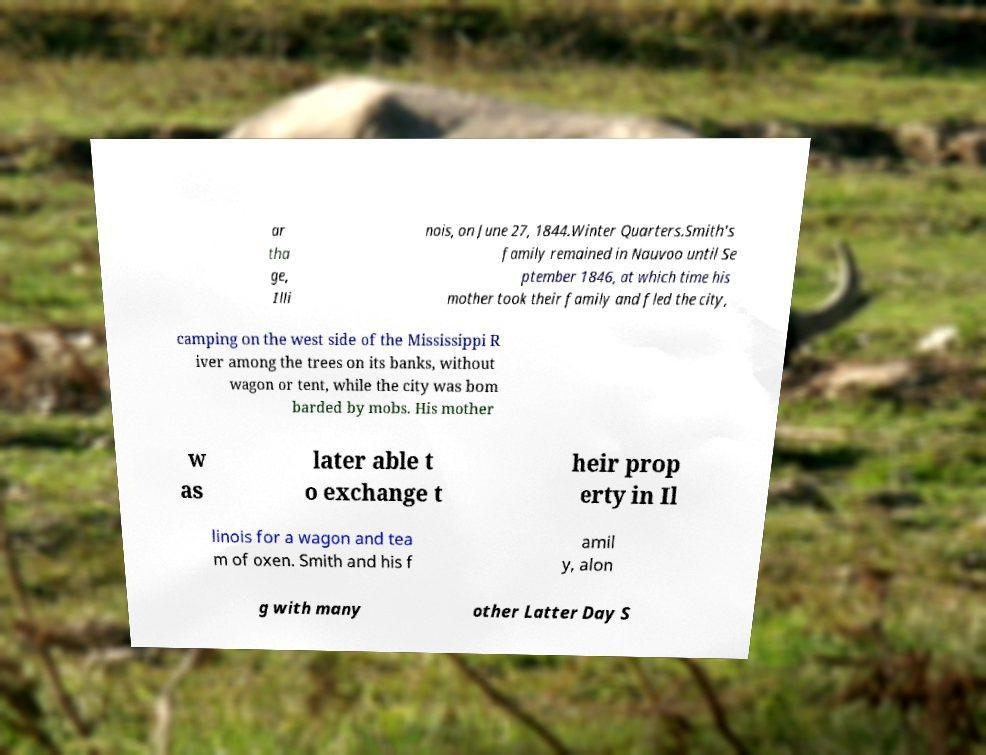Could you assist in decoding the text presented in this image and type it out clearly? ar tha ge, Illi nois, on June 27, 1844.Winter Quarters.Smith's family remained in Nauvoo until Se ptember 1846, at which time his mother took their family and fled the city, camping on the west side of the Mississippi R iver among the trees on its banks, without wagon or tent, while the city was bom barded by mobs. His mother w as later able t o exchange t heir prop erty in Il linois for a wagon and tea m of oxen. Smith and his f amil y, alon g with many other Latter Day S 